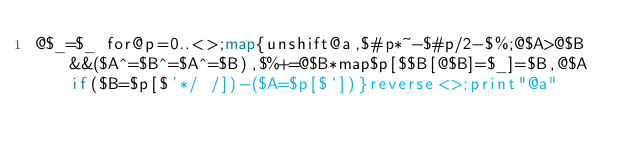<code> <loc_0><loc_0><loc_500><loc_500><_Perl_>@$_=$_ for@p=0..<>;map{unshift@a,$#p*~-$#p/2-$%;@$A>@$B&&($A^=$B^=$A^=$B),$%+=@$B*map$p[$$B[@$B]=$_]=$B,@$A if($B=$p[$'*/ /])-($A=$p[$`])}reverse<>;print"@a"</code> 